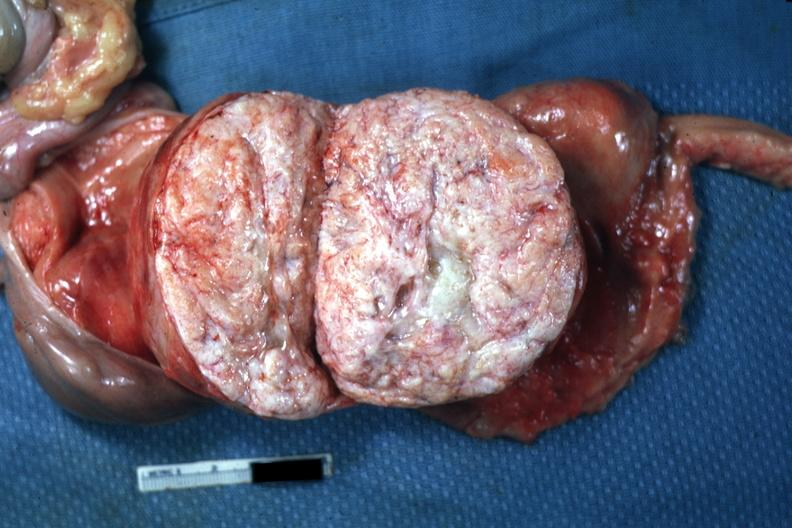s female reproductive present?
Answer the question using a single word or phrase. Yes 